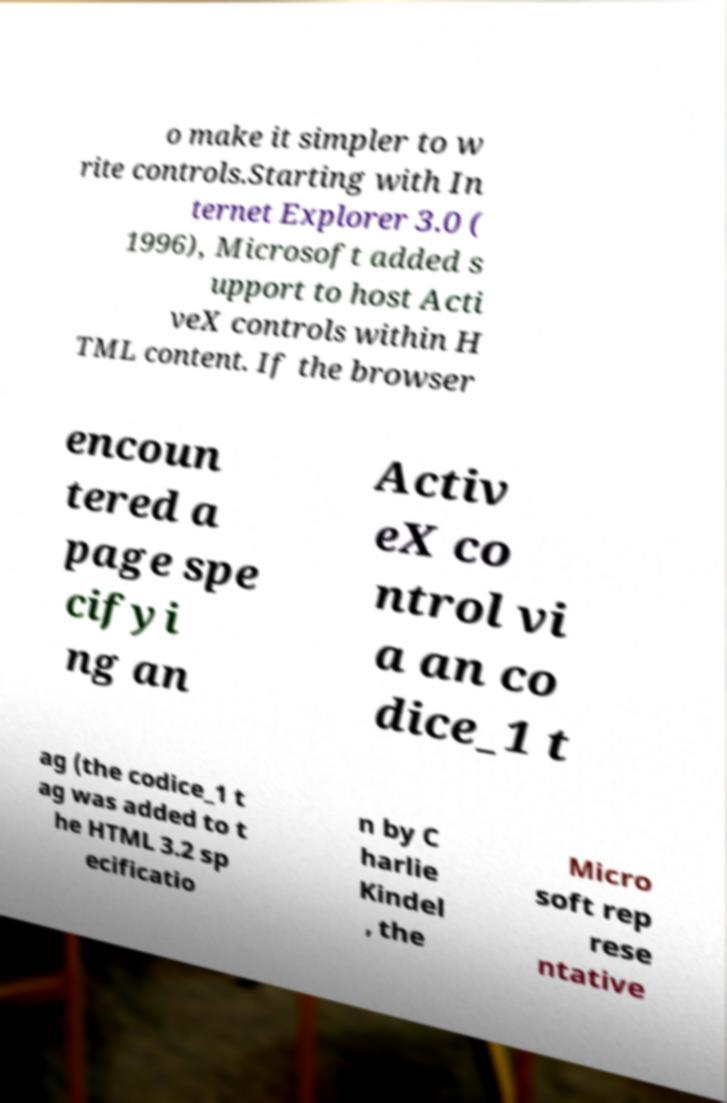Could you assist in decoding the text presented in this image and type it out clearly? o make it simpler to w rite controls.Starting with In ternet Explorer 3.0 ( 1996), Microsoft added s upport to host Acti veX controls within H TML content. If the browser encoun tered a page spe cifyi ng an Activ eX co ntrol vi a an co dice_1 t ag (the codice_1 t ag was added to t he HTML 3.2 sp ecificatio n by C harlie Kindel , the Micro soft rep rese ntative 